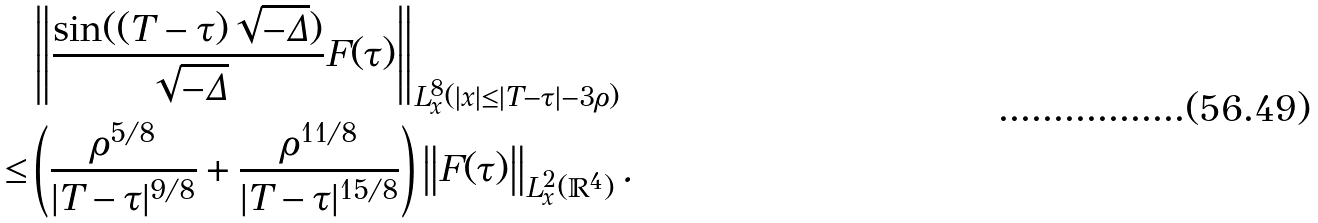Convert formula to latex. <formula><loc_0><loc_0><loc_500><loc_500>& \left \| \frac { \sin ( ( T - \tau ) \sqrt { - \Delta } ) } { \sqrt { - \Delta } } F ( \tau ) \right \| _ { L _ { x } ^ { 8 } ( | x | \leq | T - \tau | - 3 \rho ) } \\ \leq & \left ( \frac { \rho ^ { 5 / 8 } } { | T - \tau | ^ { 9 / 8 } } + \frac { \rho ^ { 1 1 / 8 } } { | T - \tau | ^ { 1 5 / 8 } } \right ) \left \| F ( \tau ) \right \| _ { L _ { x } ^ { 2 } ( \mathbb { R } ^ { 4 } ) } .</formula> 